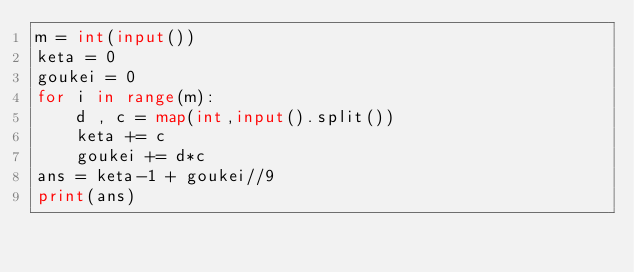<code> <loc_0><loc_0><loc_500><loc_500><_Python_>m = int(input())
keta = 0
goukei = 0
for i in range(m):
    d , c = map(int,input().split())
    keta += c
    goukei += d*c
ans = keta-1 + goukei//9
print(ans)</code> 